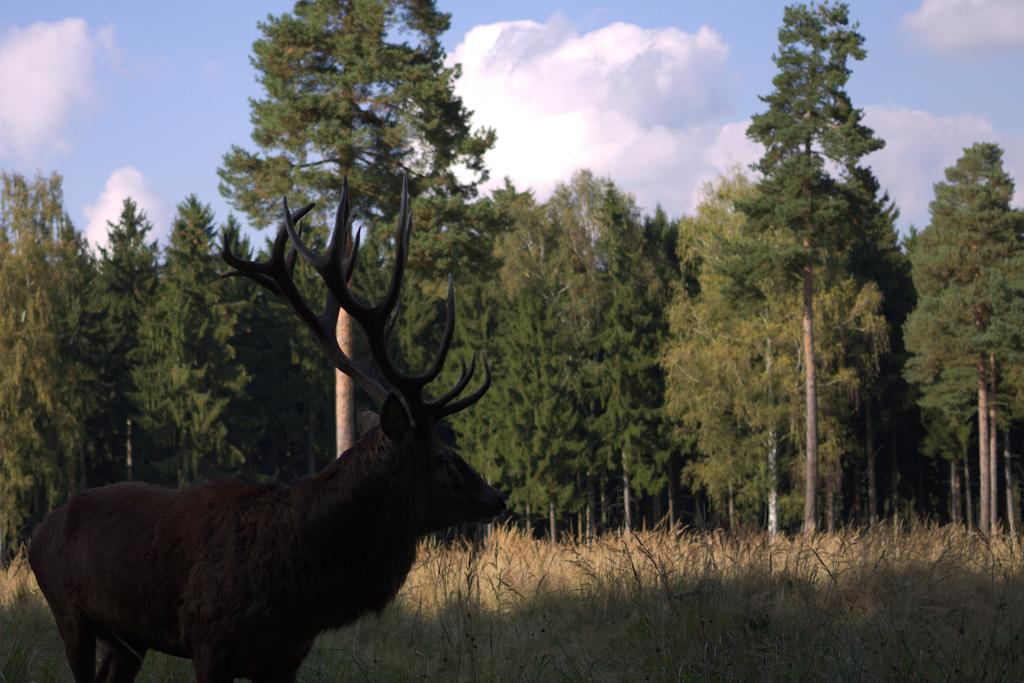What animal is standing in the image? There is a deer standing in the image. What color is the grass in the background of the image? The grass in the background of the image is yellow. What other natural elements can be seen in the background of the image? There are trees and clouds visible in the background of the image. What part of the sky is visible in the image? The sky is visible in the background of the image. What type of fowl can be seen playing chess in the image? There is no fowl or chess game present in the image; it features a deer standing in a natural environment. What type of waves can be seen in the image? There are no waves present in the image; it features a deer standing in a natural environment with yellow grass, trees, clouds, and the sky visible in the background. 